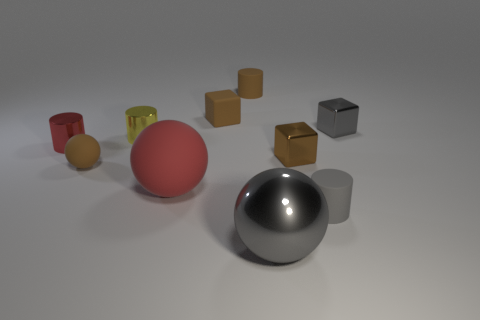Subtract all tiny balls. How many balls are left? 2 Subtract all gray spheres. How many spheres are left? 2 Subtract 1 balls. How many balls are left? 2 Subtract all cylinders. How many objects are left? 6 Add 4 tiny gray matte cylinders. How many tiny gray matte cylinders are left? 5 Add 4 green cylinders. How many green cylinders exist? 4 Subtract 2 brown blocks. How many objects are left? 8 Subtract all gray blocks. Subtract all gray cylinders. How many blocks are left? 2 Subtract all yellow cylinders. How many cyan balls are left? 0 Subtract all tiny gray matte cylinders. Subtract all large gray rubber spheres. How many objects are left? 9 